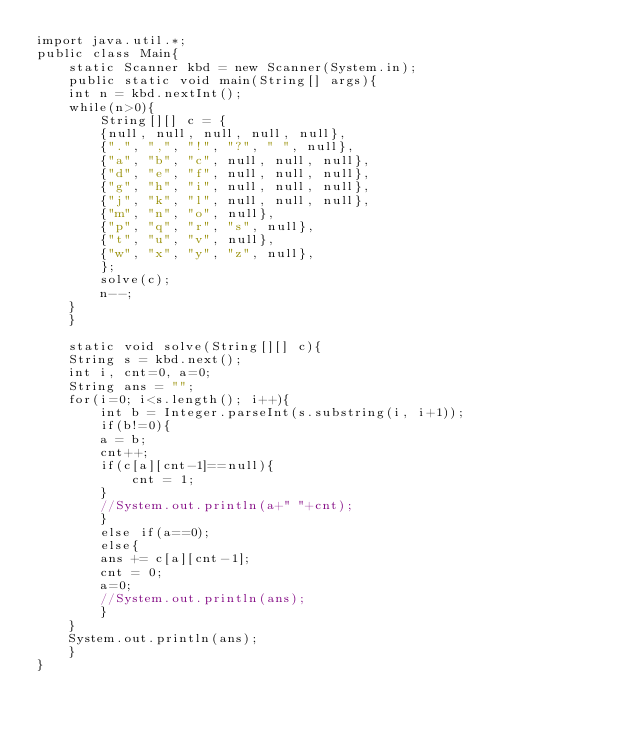<code> <loc_0><loc_0><loc_500><loc_500><_Java_>import java.util.*;
public class Main{
    static Scanner kbd = new Scanner(System.in);
    public static void main(String[] args){
	int n = kbd.nextInt();
	while(n>0){
	    String[][] c = {
		{null, null, null, null, null},
		{".", ",", "!", "?", " ", null},
		{"a", "b", "c", null, null, null},
		{"d", "e", "f", null, null, null},
		{"g", "h", "i", null, null, null},
		{"j", "k", "l", null, null, null},
		{"m", "n", "o", null},
		{"p", "q", "r", "s", null},
		{"t", "u", "v", null},
		{"w", "x", "y", "z", null},
	    };
	    solve(c);
	    n--;
	}
    }

    static void solve(String[][] c){
	String s = kbd.next();
	int i, cnt=0, a=0;
	String ans = "";
	for(i=0; i<s.length(); i++){
	    int b = Integer.parseInt(s.substring(i, i+1));
	    if(b!=0){
		a = b;
		cnt++;
		if(c[a][cnt-1]==null){
		    cnt = 1;
		}
		//System.out.println(a+" "+cnt);
	    }
	    else if(a==0);
	    else{
		ans += c[a][cnt-1];
		cnt = 0;
		a=0;
		//System.out.println(ans);
	    }
	}
	System.out.println(ans);
    }
}</code> 